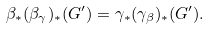Convert formula to latex. <formula><loc_0><loc_0><loc_500><loc_500>\beta _ { * } ( \beta _ { \gamma } ) _ { * } ( G ^ { \prime } ) = \gamma _ { * } ( \gamma _ { \beta } ) _ { * } ( G ^ { \prime } ) .</formula> 